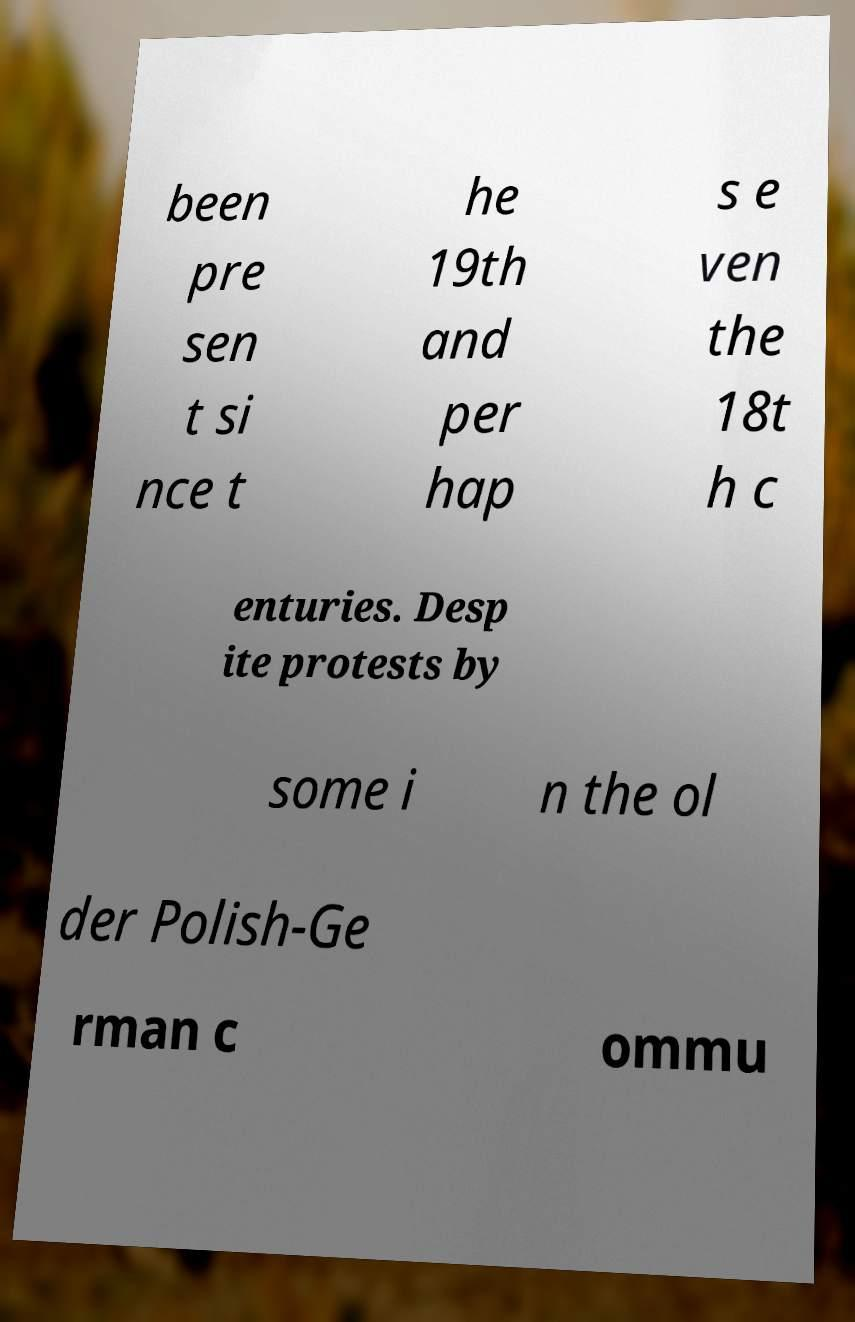I need the written content from this picture converted into text. Can you do that? been pre sen t si nce t he 19th and per hap s e ven the 18t h c enturies. Desp ite protests by some i n the ol der Polish-Ge rman c ommu 